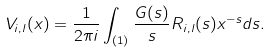Convert formula to latex. <formula><loc_0><loc_0><loc_500><loc_500>V _ { i , l } ( x ) = \frac { 1 } { 2 \pi i } \int _ { ( 1 ) } \frac { G ( s ) } { s } R _ { i , l } ( s ) x ^ { - s } d s .</formula> 